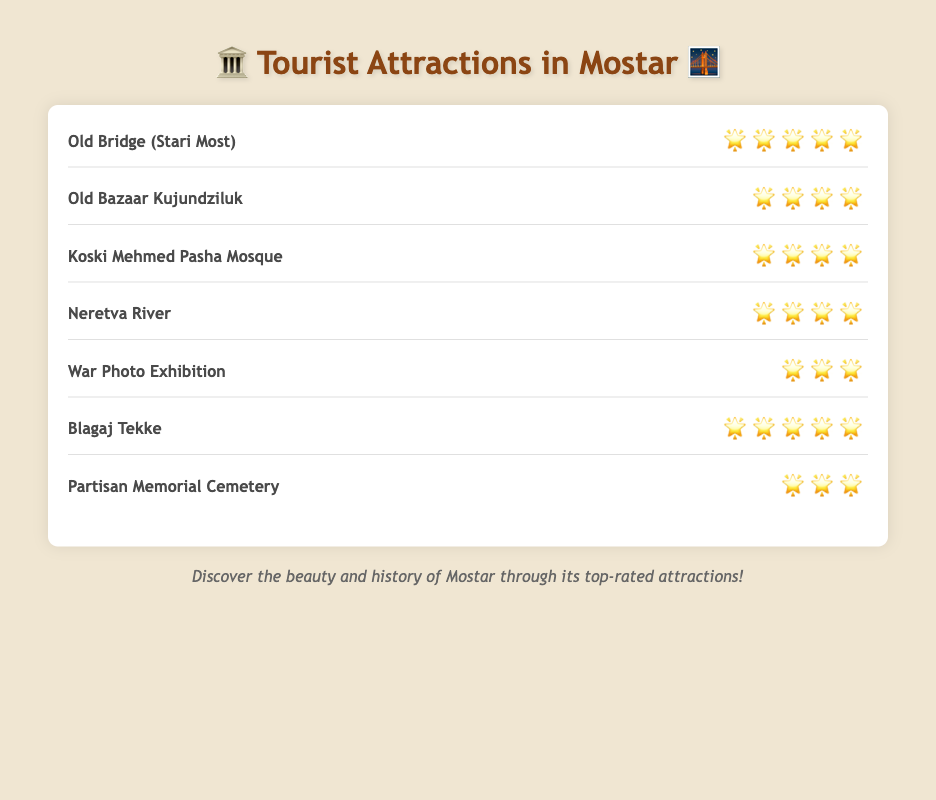What's the highest-rated tourist attraction in Mostar? The chart lists the Old Bridge (Stari Most) and Blagaj Tekke as having the highest rating of 🌟🌟🌟🌟🌟.
Answer: Old Bridge (Stari Most) and Blagaj Tekke How many attractions have a rating of four stars? The chart shows that Old Bazaar Kujundziluk, Koski Mehmed Pasha Mosque, and Neretva River each have a rating of 🌟🌟🌟🌟. This means there are three attractions with four stars.
Answer: 3 Which attractions have a rating of three stars? By looking at the ratings, War Photo Exhibition and Partisan Memorial Cemetery each have a rating of 🌟🌟🌟.
Answer: War Photo Exhibition and Partisan Memorial Cemetery What is the average star rating of all the tourist attractions? Sum the star ratings: Old Bridge (5) + Old Bazaar Kujundziluk (4) + Koski Mehmed Pasha Mosque (4) + Neretva River (4) + War Photo Exhibition (3) + Blagaj Tekke (5) + Partisan Memorial Cemetery (3) = 28 stars. There are 7 attractions, so the average rating is 28/7 = 4 stars.
Answer: 4 Compare the rating of Neretva River to Koski Mehmed Pasha Mosque. Which one has a higher rating? Both the Neretva River and Koski Mehmed Pasha Mosque have a rating of 🌟🌟🌟🌟. Therefore, they have the same rating.
Answer: Same rating How many attractions have a perfect star rating? The chart shows that Old Bridge (Stari Most) and Blagaj Tekke each have a rating of 🌟🌟🌟🌟🌟. Therefore, there are two attractions with a perfect rating.
Answer: 2 Which attraction has a better rating: Old Bazaar Kujundziluk or War Photo Exhibition? Old Bazaar Kujundziluk has a rating of 🌟🌟🌟🌟, while War Photo Exhibition has a rating of 🌟🌟🌟. Therefore, Old Bazaar Kujundziluk has a better rating.
Answer: Old Bazaar Kujundziluk Is there any attraction with exactly four-and-a-half stars? The chart only lists whole star ratings for all attractions. There are no attractions with a four-and-a-half star rating.
Answer: No What's the total number of stars for all attractions combined? Sum the star ratings: Old Bridge (5) + Old Bazaar Kujundziluk (4) + Koski Mehmed Pasha Mosque (4) + Neretva River (4) + War Photo Exhibition (3) + Blagaj Tekke (5) + Partisan Memorial Cemetery (3) = 28 stars in total.
Answer: 28 Which attraction has a rating of three stars but is not a cemetery? From the chart, the War Photo Exhibition has a rating of 🌟🌟🌟 and is not a cemetery.
Answer: War Photo Exhibition 